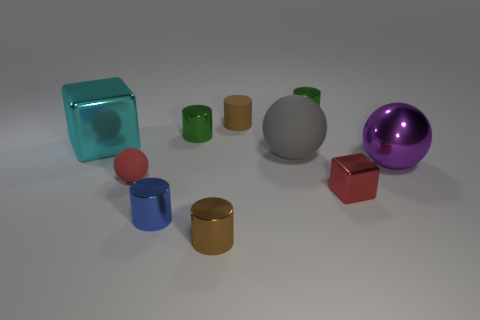There is a tiny red thing that is right of the brown cylinder behind the small rubber sphere; are there any tiny red balls on the right side of it?
Your answer should be very brief. No. There is a blue thing in front of the purple metallic object; does it have the same shape as the cyan shiny object?
Offer a very short reply. No. The matte object that is behind the metallic block behind the tiny red matte object is what shape?
Give a very brief answer. Cylinder. There is a brown cylinder that is in front of the small rubber ball that is behind the shiny block in front of the big cyan shiny object; what size is it?
Offer a very short reply. Small. What color is the other large matte object that is the same shape as the large purple object?
Provide a short and direct response. Gray. Do the red block and the rubber cylinder have the same size?
Provide a succinct answer. Yes. There is a ball to the right of the tiny shiny cube; what material is it?
Offer a very short reply. Metal. What number of other things are the same shape as the tiny blue object?
Give a very brief answer. 4. Does the cyan shiny object have the same shape as the big gray thing?
Make the answer very short. No. There is a brown matte thing; are there any blue metal cylinders right of it?
Make the answer very short. No. 